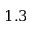Convert formula to latex. <formula><loc_0><loc_0><loc_500><loc_500>1 . 3</formula> 